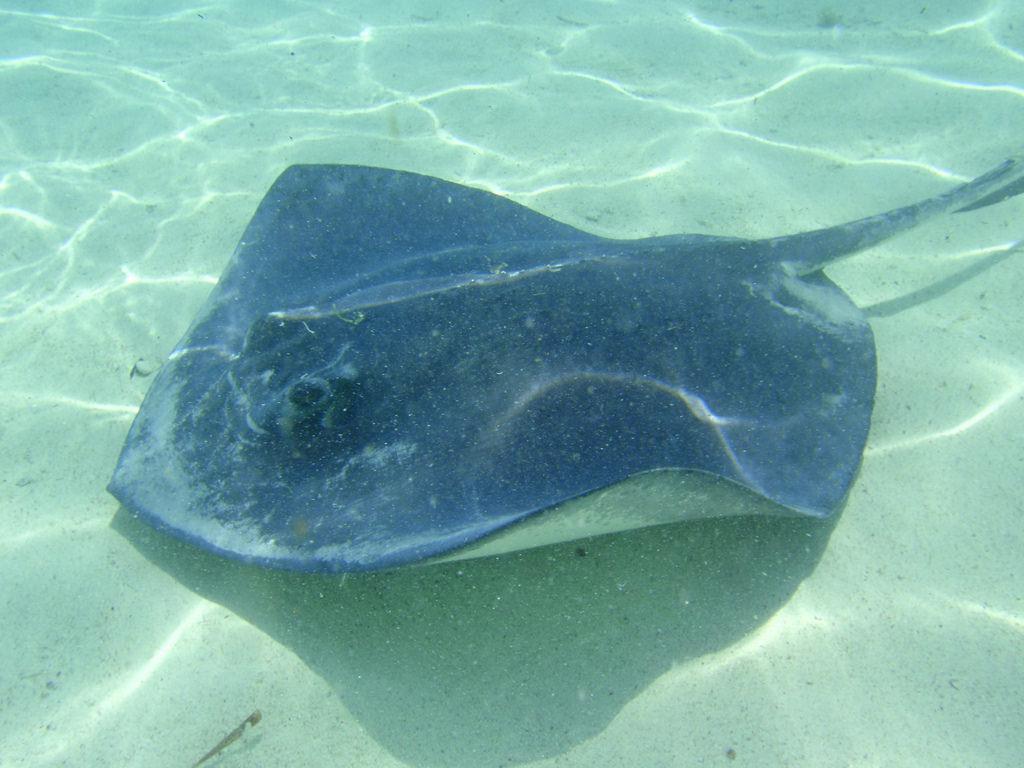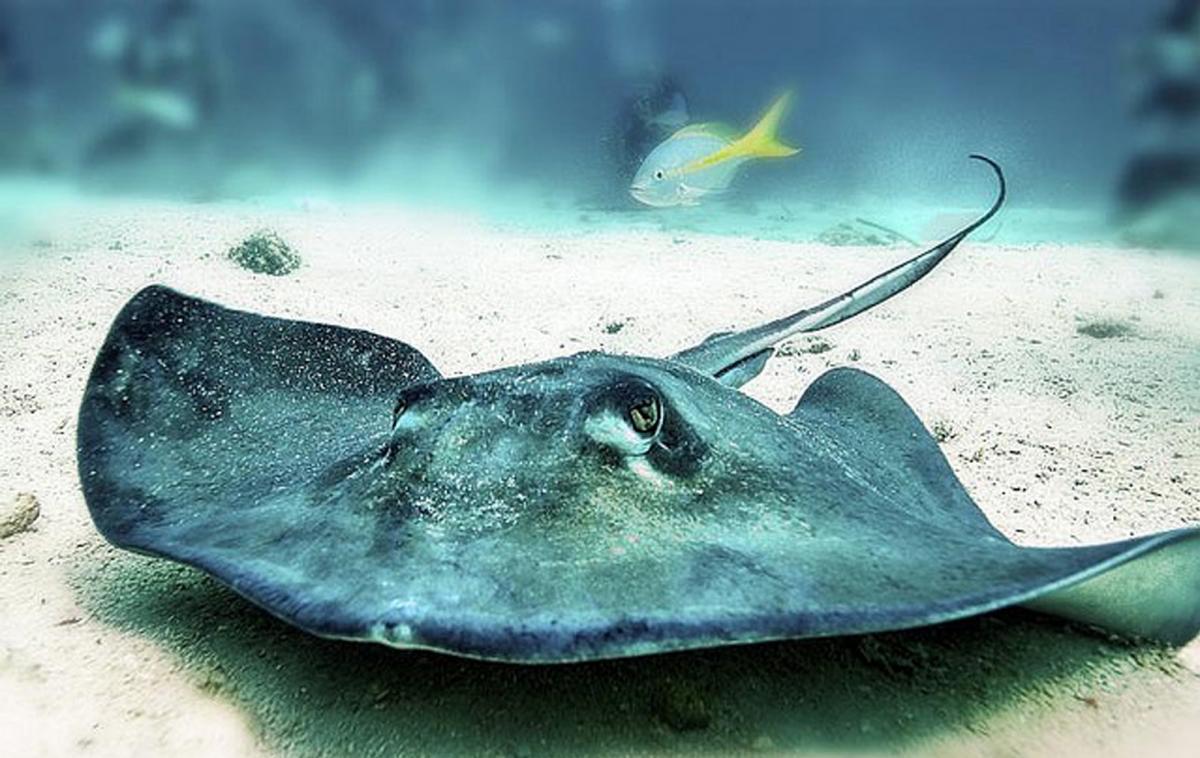The first image is the image on the left, the second image is the image on the right. Given the left and right images, does the statement "Two stingrays are swimming on the floor of the sea in the image on the right." hold true? Answer yes or no. No. 